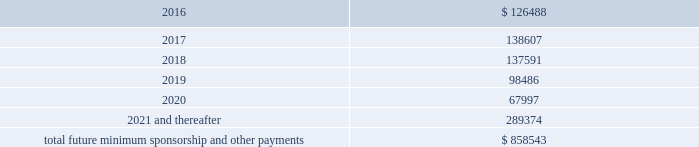Included in selling , general and administrative expense was rent expense of $ 83.0 million , $ 59.0 million and $ 41.8 million for the years ended december 31 , 2015 , 2014 and 2013 , respectively , under non-cancelable operating lease agreements .
Included in these amounts was contingent rent expense of $ 11.0 million , $ 11.0 million and $ 7.8 million for the years ended december 31 , 2015 , 2014 and 2013 , respectively .
Sports marketing and other commitments within the normal course of business , the company enters into contractual commitments in order to promote the company 2019s brand and products .
These commitments include sponsorship agreements with teams and athletes on the collegiate and professional levels , official supplier agreements , athletic event sponsorships and other marketing commitments .
The following is a schedule of the company 2019s future minimum payments under its sponsorship and other marketing agreements as of december 31 , 2015 , as well as significant sponsorship and other marketing agreements entered into during the period after december 31 , 2015 through the date of this report : ( in thousands ) .
The amounts listed above are the minimum compensation obligations and guaranteed royalty fees required to be paid under the company 2019s sponsorship and other marketing agreements .
The amounts listed above do not include additional performance incentives and product supply obligations provided under certain agreements .
It is not possible to determine how much the company will spend on product supply obligations on an annual basis as contracts generally do not stipulate specific cash amounts to be spent on products .
The amount of product provided to the sponsorships depends on many factors including general playing conditions , the number of sporting events in which they participate and the company 2019s decisions regarding product and marketing initiatives .
In addition , the costs to design , develop , source and purchase the products furnished to the endorsers are incurred over a period of time and are not necessarily tracked separately from similar costs incurred for products sold to customers .
In connection with various contracts and agreements , the company has agreed to indemnify counterparties against certain third party claims relating to the infringement of intellectual property rights and other items .
Generally , such indemnification obligations do not apply in situations in which the counterparties are grossly negligent , engage in willful misconduct , or act in bad faith .
Based on the company 2019s historical experience and the estimated probability of future loss , the company has determined that the fair value of such indemnifications is not material to its consolidated financial position or results of operations .
From time to time , the company is involved in litigation and other proceedings , including matters related to commercial and intellectual property disputes , as well as trade , regulatory and other claims related to its business .
The company believes that all current proceedings are routine in nature and incidental to the conduct of its business , and that the ultimate resolution of any such proceedings will not have a material adverse effect on its consolidated financial position , results of operations or cash flows .
Following the company 2019s announcement of the creation of a new class of common stock , referred to as the class c common stock , par value $ 0.0003 1/3 per share , four purported class action lawsuits were brought .
What was the percent change in rent expense included in the the selling , general and administrative expense from 2014 to 2015? 
Computations: ((83.0 - 59.0) / 59.0)
Answer: 0.40678. 